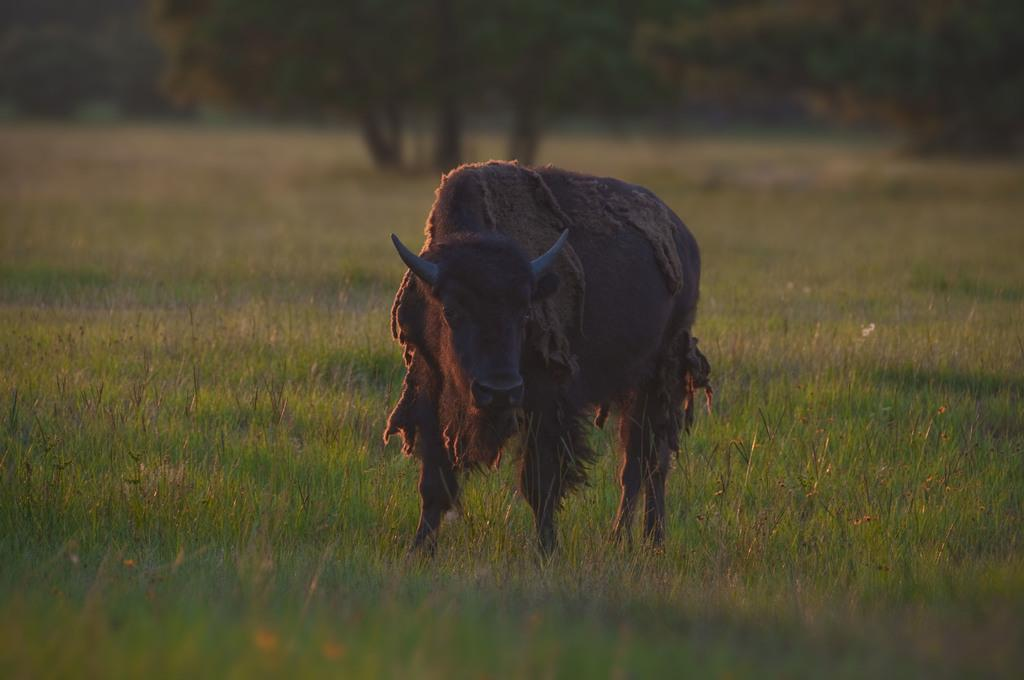What type of animal is in the image? There is a wild bull in the image. What is the color of the wild bull? The wild bull is brown in color. What is the position of the wild bull in the image? The wild bull is standing. What can be seen in the background of the image? There are trees in the background of the image. Can you see any signs of an earthquake in the image? There is no indication of an earthquake in the image. Is there a kitty playing with the wild bull in the image? There is no kitty present in the image. 